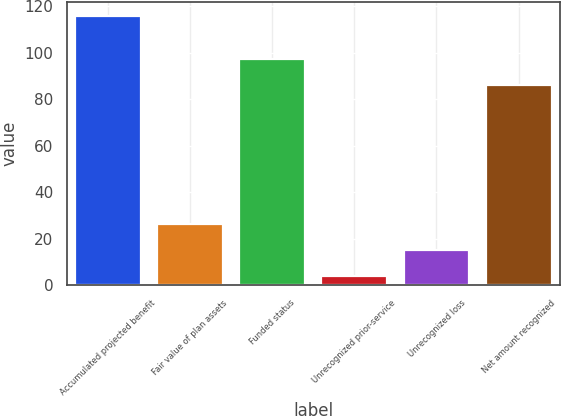<chart> <loc_0><loc_0><loc_500><loc_500><bar_chart><fcel>Accumulated projected benefit<fcel>Fair value of plan assets<fcel>Funded status<fcel>Unrecognized prior-service<fcel>Unrecognized loss<fcel>Net amount recognized<nl><fcel>116<fcel>26.4<fcel>97.2<fcel>4<fcel>15.2<fcel>86<nl></chart> 